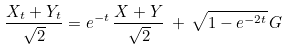<formula> <loc_0><loc_0><loc_500><loc_500>\frac { X _ { t } + Y _ { t } } { \sqrt { 2 } } = e ^ { - t } \, \frac { X + Y } { \sqrt { 2 } } \, + \, \sqrt { 1 - e ^ { - 2 t } } \, G</formula> 